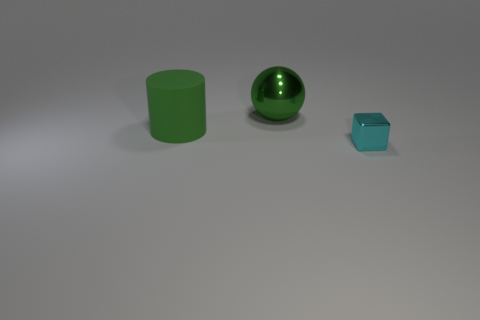Are the shadows consistent with the lighting in the scene? Yes, all objects cast shadows that extend to the right, suggesting a light source to the left of the scene, which is consistent with the soft shadows present. Could you estimate the time of day if this was outdoors? If this were an outdoor scene, the relatively soft and diffused shadows might suggest an overcast day or a time when the sun is not at its peak, such as morning or late afternoon. 